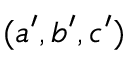<formula> <loc_0><loc_0><loc_500><loc_500>( a ^ { \prime } , b ^ { \prime } , c ^ { \prime } )</formula> 